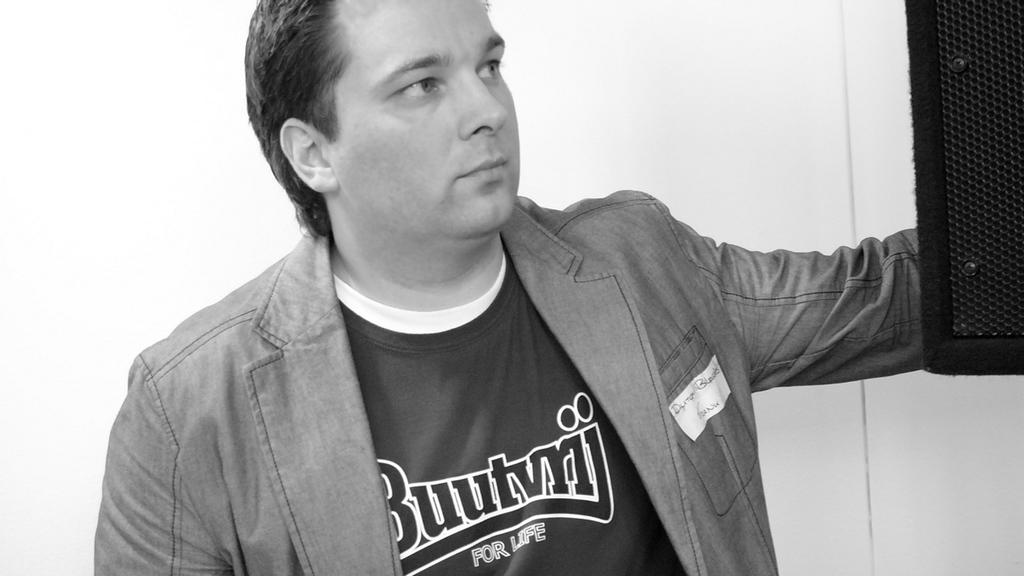What name is on his shirt?
Provide a short and direct response. Buutvrij. According to his shirt, what is for life?
Your response must be concise. Buutvrij. 